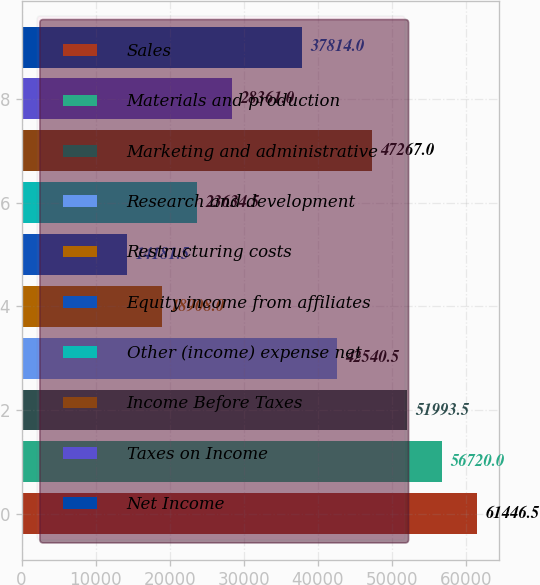Convert chart. <chart><loc_0><loc_0><loc_500><loc_500><bar_chart><fcel>Sales<fcel>Materials and production<fcel>Marketing and administrative<fcel>Research and development<fcel>Restructuring costs<fcel>Equity income from affiliates<fcel>Other (income) expense net<fcel>Income Before Taxes<fcel>Taxes on Income<fcel>Net Income<nl><fcel>61446.5<fcel>56720<fcel>51993.5<fcel>42540.5<fcel>18908<fcel>14181.5<fcel>23634.5<fcel>47267<fcel>28361<fcel>37814<nl></chart> 